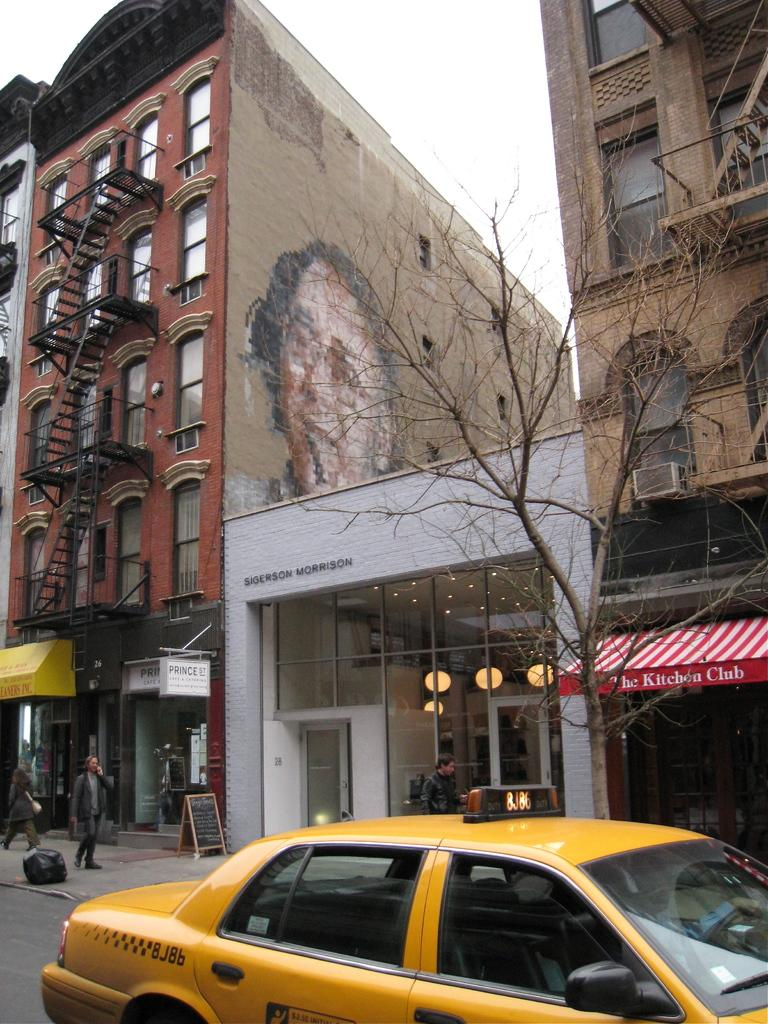<image>
Summarize the visual content of the image. A mural of a man's face is painted on the side of a building above a Sigerson Morrison store. 